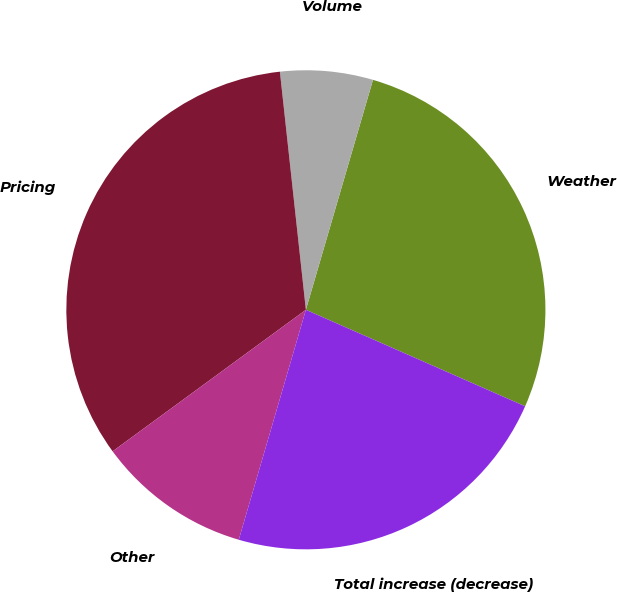<chart> <loc_0><loc_0><loc_500><loc_500><pie_chart><fcel>Weather<fcel>Volume<fcel>Pricing<fcel>Other<fcel>Total increase (decrease)<nl><fcel>27.08%<fcel>6.25%<fcel>33.33%<fcel>10.42%<fcel>22.92%<nl></chart> 